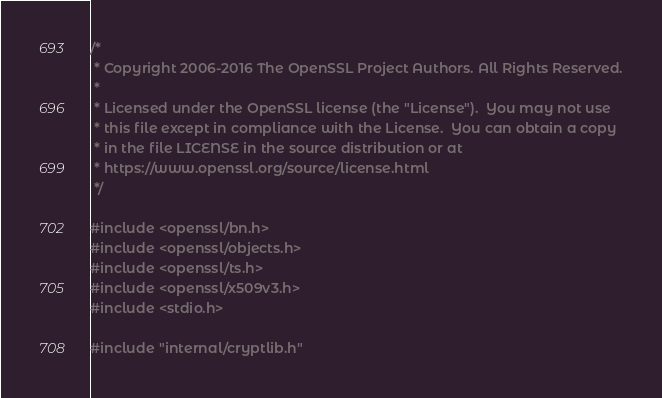<code> <loc_0><loc_0><loc_500><loc_500><_C_>/*
 * Copyright 2006-2016 The OpenSSL Project Authors. All Rights Reserved.
 *
 * Licensed under the OpenSSL license (the "License").  You may not use
 * this file except in compliance with the License.  You can obtain a copy
 * in the file LICENSE in the source distribution or at
 * https://www.openssl.org/source/license.html
 */

#include <openssl/bn.h>
#include <openssl/objects.h>
#include <openssl/ts.h>
#include <openssl/x509v3.h>
#include <stdio.h>

#include "internal/cryptlib.h"</code> 